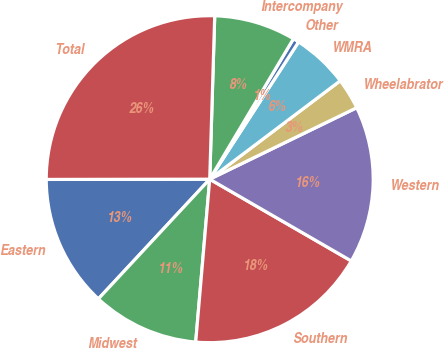Convert chart. <chart><loc_0><loc_0><loc_500><loc_500><pie_chart><fcel>Eastern<fcel>Midwest<fcel>Southern<fcel>Western<fcel>Wheelabrator<fcel>WMRA<fcel>Other<fcel>Intercompany<fcel>Total<nl><fcel>13.05%<fcel>10.56%<fcel>18.03%<fcel>15.54%<fcel>3.08%<fcel>5.57%<fcel>0.59%<fcel>8.07%<fcel>25.51%<nl></chart> 